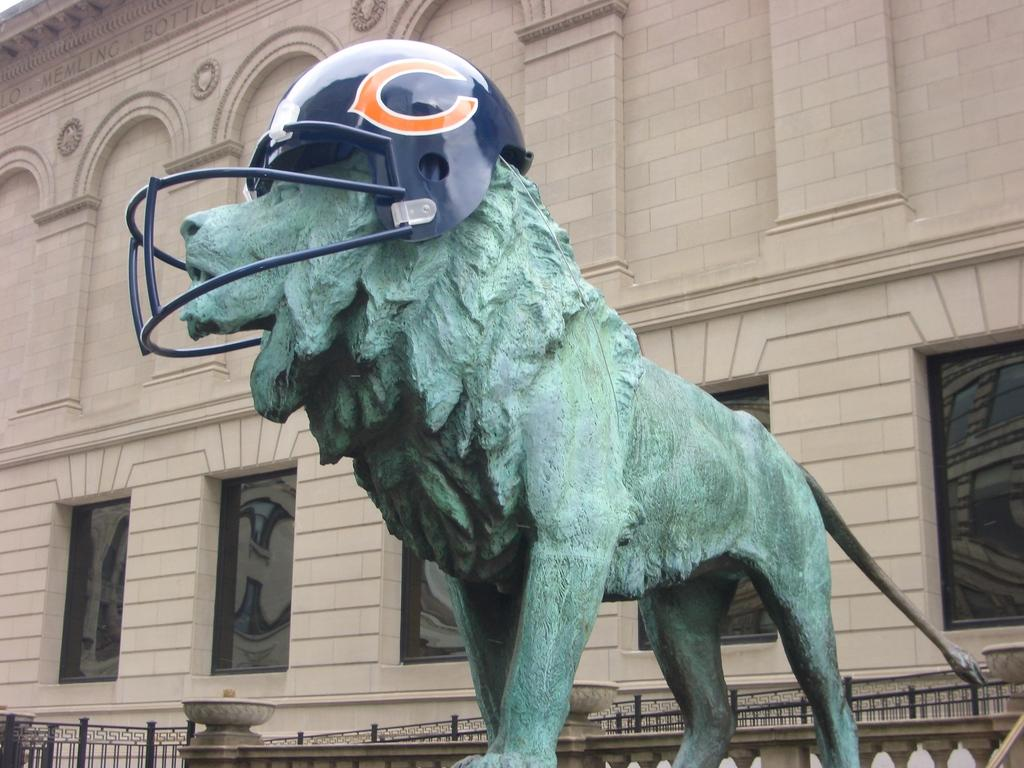What type of structure is visible in the image? There is a building in the image. What can be seen near the building? There is a railing and a statue of a lion in the foreground. What is the lion statue wearing? The lion statue has a helmet on it. What type of drink is the zebra holding in the image? There is no zebra present in the image, so it cannot be holding any drink. 